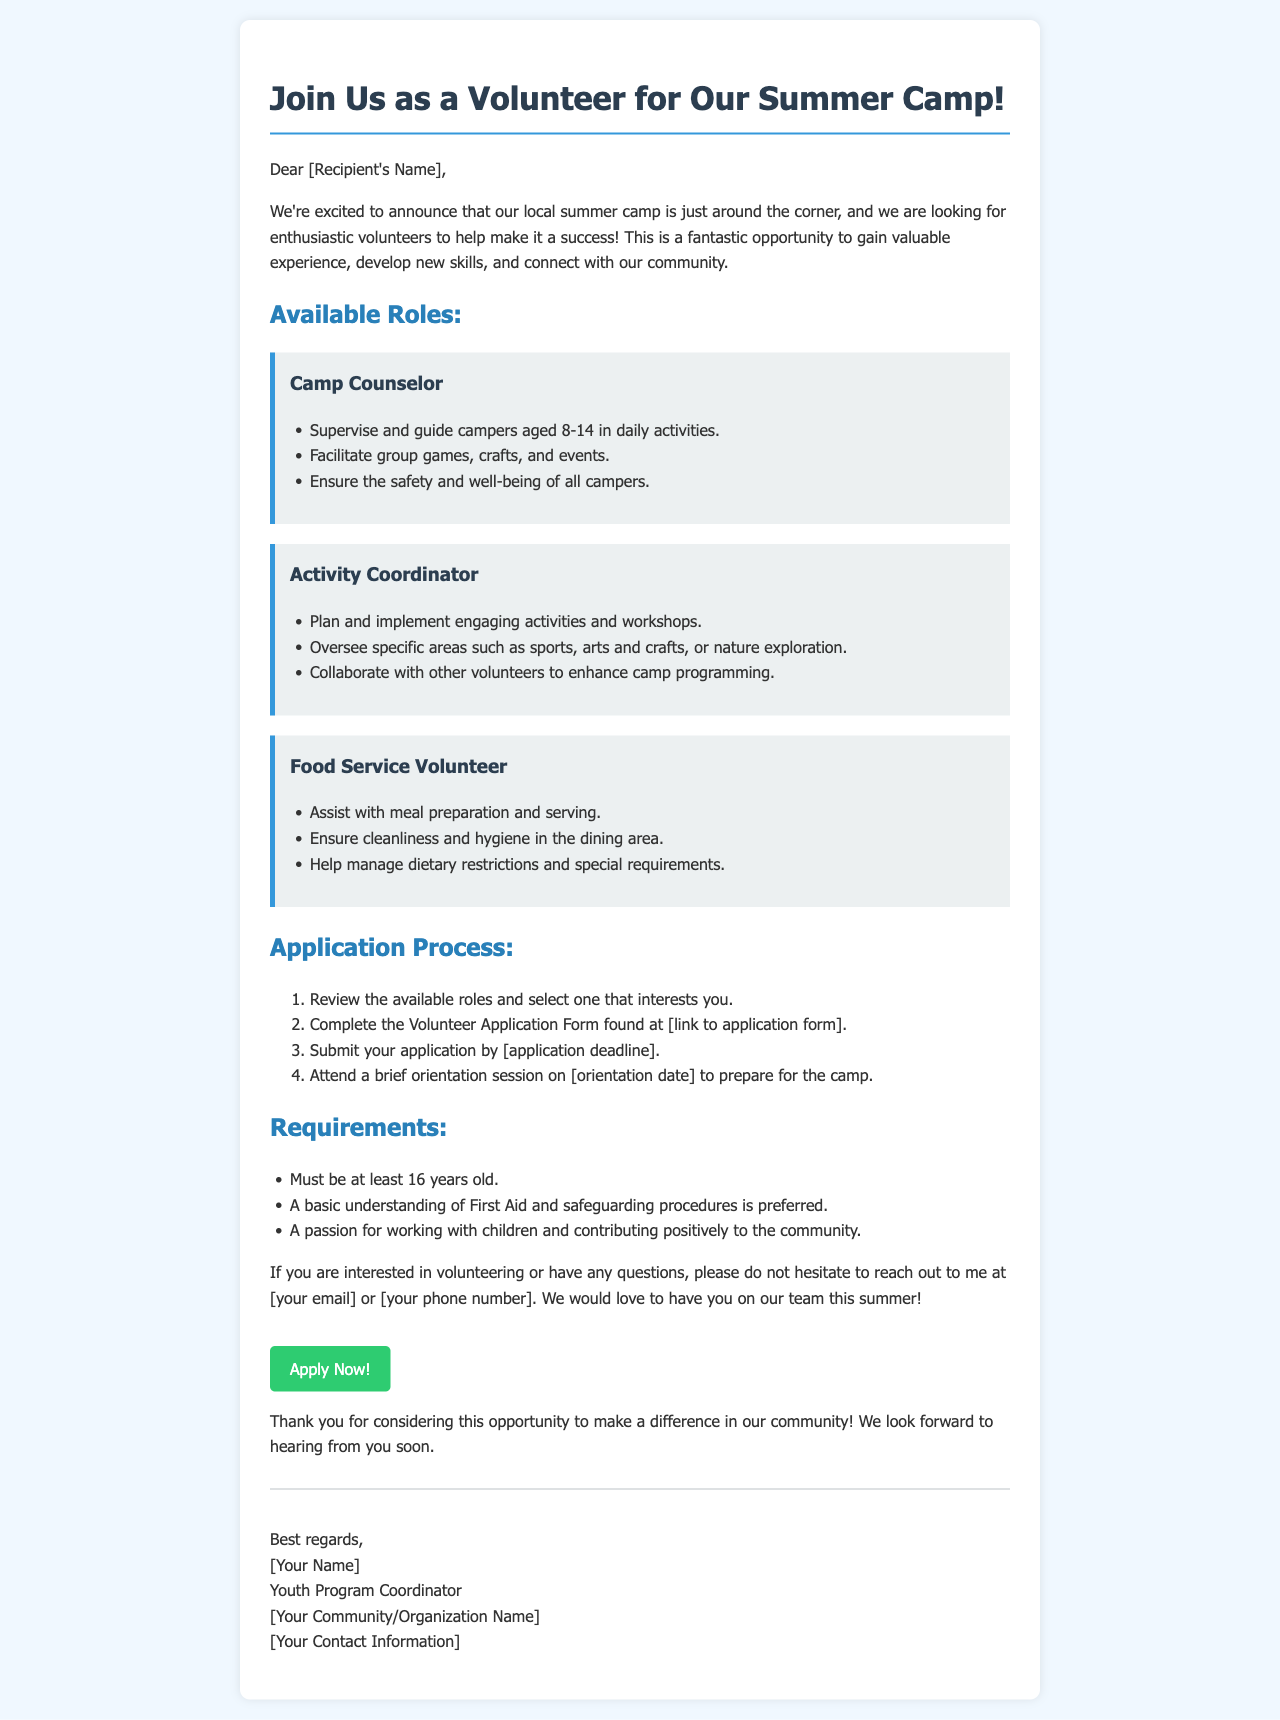What are the available volunteer roles? The document lists the available volunteer roles as Camp Counselor, Activity Coordinator, and Food Service Volunteer.
Answer: Camp Counselor, Activity Coordinator, and Food Service Volunteer What is the minimum age requirement to volunteer? The document states that volunteers must be at least 16 years old.
Answer: 16 years old When is the application deadline? The application deadline is indicated as [application deadline] in the document, which is a placeholder for specific information.
Answer: [application deadline] What type of understanding is preferred for applicants? The document mentions that a basic understanding of First Aid and safeguarding procedures is preferred.
Answer: First Aid and safeguarding What activity does a Camp Counselor oversee? The Camp Counselor is responsible for supervising and guiding campers in daily activities.
Answer: Daily activities How many steps are in the application process? The document outlines four steps in the application process.
Answer: Four Who should be contacted for questions regarding volunteering? The document suggests reaching out to the Youth Program Coordinator for any questions regarding volunteering.
Answer: Youth Program Coordinator What is the benefit of volunteering mentioned in the email? The email highlights gaining valuable experience as an advantage of volunteering.
Answer: Valuable experience 